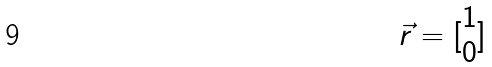Convert formula to latex. <formula><loc_0><loc_0><loc_500><loc_500>\vec { r } = [ \begin{matrix} 1 \\ 0 \end{matrix} ]</formula> 